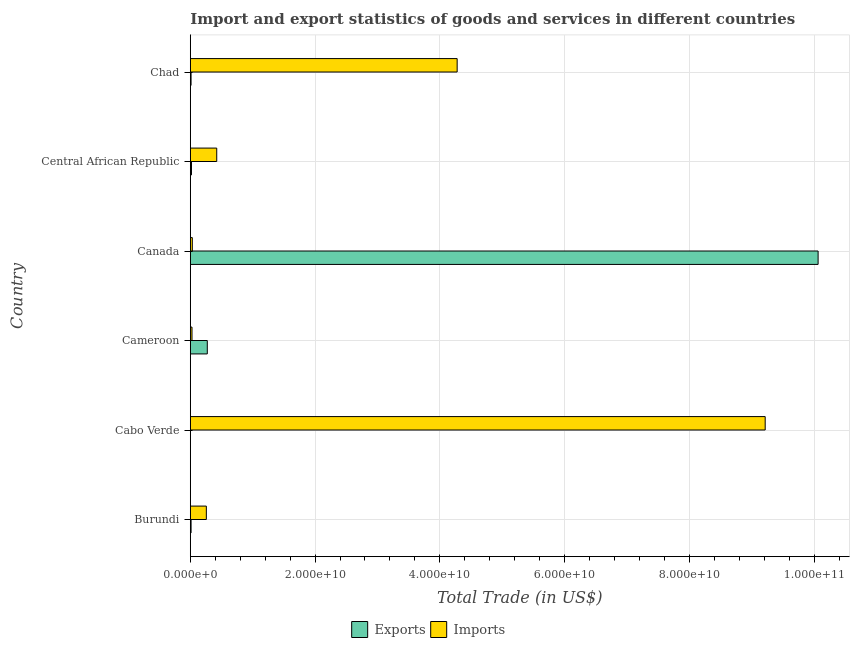Are the number of bars per tick equal to the number of legend labels?
Your answer should be very brief. Yes. What is the label of the 1st group of bars from the top?
Give a very brief answer. Chad. What is the imports of goods and services in Cabo Verde?
Offer a terse response. 9.22e+1. Across all countries, what is the maximum export of goods and services?
Offer a very short reply. 1.01e+11. Across all countries, what is the minimum imports of goods and services?
Offer a terse response. 2.74e+08. In which country was the imports of goods and services maximum?
Your response must be concise. Cabo Verde. In which country was the imports of goods and services minimum?
Your response must be concise. Cameroon. What is the total imports of goods and services in the graph?
Your answer should be compact. 1.42e+11. What is the difference between the export of goods and services in Cameroon and that in Chad?
Offer a very short reply. 2.60e+09. What is the difference between the export of goods and services in Burundi and the imports of goods and services in Cabo Verde?
Provide a succinct answer. -9.20e+1. What is the average export of goods and services per country?
Provide a succinct answer. 1.73e+1. What is the difference between the imports of goods and services and export of goods and services in Central African Republic?
Your response must be concise. 4.05e+09. What is the ratio of the imports of goods and services in Cameroon to that in Chad?
Provide a short and direct response. 0.01. Is the export of goods and services in Cameroon less than that in Chad?
Your answer should be very brief. No. Is the difference between the imports of goods and services in Cabo Verde and Central African Republic greater than the difference between the export of goods and services in Cabo Verde and Central African Republic?
Offer a terse response. Yes. What is the difference between the highest and the second highest export of goods and services?
Provide a succinct answer. 9.79e+1. What is the difference between the highest and the lowest export of goods and services?
Ensure brevity in your answer.  1.01e+11. In how many countries, is the export of goods and services greater than the average export of goods and services taken over all countries?
Your answer should be compact. 1. What does the 2nd bar from the top in Canada represents?
Keep it short and to the point. Exports. What does the 1st bar from the bottom in Chad represents?
Keep it short and to the point. Exports. Does the graph contain any zero values?
Ensure brevity in your answer.  No. Does the graph contain grids?
Offer a terse response. Yes. How are the legend labels stacked?
Offer a terse response. Horizontal. What is the title of the graph?
Offer a terse response. Import and export statistics of goods and services in different countries. What is the label or title of the X-axis?
Your answer should be very brief. Total Trade (in US$). What is the label or title of the Y-axis?
Make the answer very short. Country. What is the Total Trade (in US$) of Exports in Burundi?
Your answer should be very brief. 1.27e+08. What is the Total Trade (in US$) in Imports in Burundi?
Offer a terse response. 2.57e+09. What is the Total Trade (in US$) of Exports in Cabo Verde?
Ensure brevity in your answer.  3.12e+07. What is the Total Trade (in US$) in Imports in Cabo Verde?
Your answer should be compact. 9.22e+1. What is the Total Trade (in US$) in Exports in Cameroon?
Provide a succinct answer. 2.73e+09. What is the Total Trade (in US$) in Imports in Cameroon?
Give a very brief answer. 2.74e+08. What is the Total Trade (in US$) of Exports in Canada?
Offer a terse response. 1.01e+11. What is the Total Trade (in US$) of Imports in Canada?
Provide a succinct answer. 3.24e+08. What is the Total Trade (in US$) in Exports in Central African Republic?
Offer a very short reply. 1.90e+08. What is the Total Trade (in US$) of Imports in Central African Republic?
Give a very brief answer. 4.24e+09. What is the Total Trade (in US$) of Exports in Chad?
Your answer should be compact. 1.23e+08. What is the Total Trade (in US$) of Imports in Chad?
Your answer should be compact. 4.28e+1. Across all countries, what is the maximum Total Trade (in US$) of Exports?
Ensure brevity in your answer.  1.01e+11. Across all countries, what is the maximum Total Trade (in US$) of Imports?
Keep it short and to the point. 9.22e+1. Across all countries, what is the minimum Total Trade (in US$) of Exports?
Your answer should be compact. 3.12e+07. Across all countries, what is the minimum Total Trade (in US$) of Imports?
Your response must be concise. 2.74e+08. What is the total Total Trade (in US$) in Exports in the graph?
Offer a very short reply. 1.04e+11. What is the total Total Trade (in US$) of Imports in the graph?
Your answer should be very brief. 1.42e+11. What is the difference between the Total Trade (in US$) in Exports in Burundi and that in Cabo Verde?
Your answer should be very brief. 9.56e+07. What is the difference between the Total Trade (in US$) in Imports in Burundi and that in Cabo Verde?
Your response must be concise. -8.96e+1. What is the difference between the Total Trade (in US$) of Exports in Burundi and that in Cameroon?
Make the answer very short. -2.60e+09. What is the difference between the Total Trade (in US$) in Imports in Burundi and that in Cameroon?
Provide a succinct answer. 2.30e+09. What is the difference between the Total Trade (in US$) in Exports in Burundi and that in Canada?
Make the answer very short. -1.01e+11. What is the difference between the Total Trade (in US$) of Imports in Burundi and that in Canada?
Your answer should be very brief. 2.25e+09. What is the difference between the Total Trade (in US$) in Exports in Burundi and that in Central African Republic?
Offer a very short reply. -6.35e+07. What is the difference between the Total Trade (in US$) of Imports in Burundi and that in Central African Republic?
Give a very brief answer. -1.67e+09. What is the difference between the Total Trade (in US$) of Exports in Burundi and that in Chad?
Your response must be concise. 3.80e+06. What is the difference between the Total Trade (in US$) in Imports in Burundi and that in Chad?
Provide a succinct answer. -4.02e+1. What is the difference between the Total Trade (in US$) in Exports in Cabo Verde and that in Cameroon?
Give a very brief answer. -2.69e+09. What is the difference between the Total Trade (in US$) in Imports in Cabo Verde and that in Cameroon?
Keep it short and to the point. 9.19e+1. What is the difference between the Total Trade (in US$) in Exports in Cabo Verde and that in Canada?
Offer a terse response. -1.01e+11. What is the difference between the Total Trade (in US$) in Imports in Cabo Verde and that in Canada?
Ensure brevity in your answer.  9.18e+1. What is the difference between the Total Trade (in US$) of Exports in Cabo Verde and that in Central African Republic?
Offer a terse response. -1.59e+08. What is the difference between the Total Trade (in US$) in Imports in Cabo Verde and that in Central African Republic?
Keep it short and to the point. 8.79e+1. What is the difference between the Total Trade (in US$) in Exports in Cabo Verde and that in Chad?
Make the answer very short. -9.18e+07. What is the difference between the Total Trade (in US$) in Imports in Cabo Verde and that in Chad?
Your answer should be compact. 4.94e+1. What is the difference between the Total Trade (in US$) of Exports in Cameroon and that in Canada?
Offer a terse response. -9.79e+1. What is the difference between the Total Trade (in US$) in Imports in Cameroon and that in Canada?
Give a very brief answer. -5.00e+07. What is the difference between the Total Trade (in US$) in Exports in Cameroon and that in Central African Republic?
Your response must be concise. 2.54e+09. What is the difference between the Total Trade (in US$) of Imports in Cameroon and that in Central African Republic?
Make the answer very short. -3.97e+09. What is the difference between the Total Trade (in US$) of Exports in Cameroon and that in Chad?
Your response must be concise. 2.60e+09. What is the difference between the Total Trade (in US$) of Imports in Cameroon and that in Chad?
Give a very brief answer. -4.25e+1. What is the difference between the Total Trade (in US$) in Exports in Canada and that in Central African Republic?
Your response must be concise. 1.00e+11. What is the difference between the Total Trade (in US$) of Imports in Canada and that in Central African Republic?
Your answer should be very brief. -3.92e+09. What is the difference between the Total Trade (in US$) of Exports in Canada and that in Chad?
Your answer should be compact. 1.01e+11. What is the difference between the Total Trade (in US$) in Imports in Canada and that in Chad?
Your answer should be compact. -4.25e+1. What is the difference between the Total Trade (in US$) of Exports in Central African Republic and that in Chad?
Keep it short and to the point. 6.73e+07. What is the difference between the Total Trade (in US$) of Imports in Central African Republic and that in Chad?
Provide a succinct answer. -3.85e+1. What is the difference between the Total Trade (in US$) in Exports in Burundi and the Total Trade (in US$) in Imports in Cabo Verde?
Provide a short and direct response. -9.20e+1. What is the difference between the Total Trade (in US$) of Exports in Burundi and the Total Trade (in US$) of Imports in Cameroon?
Keep it short and to the point. -1.47e+08. What is the difference between the Total Trade (in US$) of Exports in Burundi and the Total Trade (in US$) of Imports in Canada?
Provide a short and direct response. -1.97e+08. What is the difference between the Total Trade (in US$) in Exports in Burundi and the Total Trade (in US$) in Imports in Central African Republic?
Your answer should be compact. -4.11e+09. What is the difference between the Total Trade (in US$) in Exports in Burundi and the Total Trade (in US$) in Imports in Chad?
Make the answer very short. -4.27e+1. What is the difference between the Total Trade (in US$) of Exports in Cabo Verde and the Total Trade (in US$) of Imports in Cameroon?
Make the answer very short. -2.42e+08. What is the difference between the Total Trade (in US$) of Exports in Cabo Verde and the Total Trade (in US$) of Imports in Canada?
Your response must be concise. -2.92e+08. What is the difference between the Total Trade (in US$) in Exports in Cabo Verde and the Total Trade (in US$) in Imports in Central African Republic?
Offer a very short reply. -4.21e+09. What is the difference between the Total Trade (in US$) in Exports in Cabo Verde and the Total Trade (in US$) in Imports in Chad?
Provide a succinct answer. -4.28e+1. What is the difference between the Total Trade (in US$) in Exports in Cameroon and the Total Trade (in US$) in Imports in Canada?
Keep it short and to the point. 2.40e+09. What is the difference between the Total Trade (in US$) of Exports in Cameroon and the Total Trade (in US$) of Imports in Central African Republic?
Offer a terse response. -1.51e+09. What is the difference between the Total Trade (in US$) in Exports in Cameroon and the Total Trade (in US$) in Imports in Chad?
Provide a short and direct response. -4.01e+1. What is the difference between the Total Trade (in US$) in Exports in Canada and the Total Trade (in US$) in Imports in Central African Republic?
Your answer should be very brief. 9.64e+1. What is the difference between the Total Trade (in US$) of Exports in Canada and the Total Trade (in US$) of Imports in Chad?
Provide a succinct answer. 5.79e+1. What is the difference between the Total Trade (in US$) of Exports in Central African Republic and the Total Trade (in US$) of Imports in Chad?
Keep it short and to the point. -4.26e+1. What is the average Total Trade (in US$) of Exports per country?
Your response must be concise. 1.73e+1. What is the average Total Trade (in US$) in Imports per country?
Ensure brevity in your answer.  2.37e+1. What is the difference between the Total Trade (in US$) of Exports and Total Trade (in US$) of Imports in Burundi?
Your answer should be very brief. -2.45e+09. What is the difference between the Total Trade (in US$) in Exports and Total Trade (in US$) in Imports in Cabo Verde?
Provide a succinct answer. -9.21e+1. What is the difference between the Total Trade (in US$) in Exports and Total Trade (in US$) in Imports in Cameroon?
Offer a terse response. 2.45e+09. What is the difference between the Total Trade (in US$) of Exports and Total Trade (in US$) of Imports in Canada?
Your response must be concise. 1.00e+11. What is the difference between the Total Trade (in US$) in Exports and Total Trade (in US$) in Imports in Central African Republic?
Offer a terse response. -4.05e+09. What is the difference between the Total Trade (in US$) in Exports and Total Trade (in US$) in Imports in Chad?
Keep it short and to the point. -4.27e+1. What is the ratio of the Total Trade (in US$) in Exports in Burundi to that in Cabo Verde?
Provide a short and direct response. 4.07. What is the ratio of the Total Trade (in US$) of Imports in Burundi to that in Cabo Verde?
Give a very brief answer. 0.03. What is the ratio of the Total Trade (in US$) in Exports in Burundi to that in Cameroon?
Your response must be concise. 0.05. What is the ratio of the Total Trade (in US$) in Imports in Burundi to that in Cameroon?
Offer a very short reply. 9.4. What is the ratio of the Total Trade (in US$) in Exports in Burundi to that in Canada?
Keep it short and to the point. 0. What is the ratio of the Total Trade (in US$) in Imports in Burundi to that in Canada?
Your answer should be very brief. 7.95. What is the ratio of the Total Trade (in US$) of Exports in Burundi to that in Central African Republic?
Ensure brevity in your answer.  0.67. What is the ratio of the Total Trade (in US$) of Imports in Burundi to that in Central African Republic?
Ensure brevity in your answer.  0.61. What is the ratio of the Total Trade (in US$) of Exports in Burundi to that in Chad?
Give a very brief answer. 1.03. What is the ratio of the Total Trade (in US$) of Imports in Burundi to that in Chad?
Make the answer very short. 0.06. What is the ratio of the Total Trade (in US$) in Exports in Cabo Verde to that in Cameroon?
Ensure brevity in your answer.  0.01. What is the ratio of the Total Trade (in US$) in Imports in Cabo Verde to that in Cameroon?
Keep it short and to the point. 336.87. What is the ratio of the Total Trade (in US$) of Imports in Cabo Verde to that in Canada?
Make the answer very short. 284.79. What is the ratio of the Total Trade (in US$) of Exports in Cabo Verde to that in Central African Republic?
Your response must be concise. 0.16. What is the ratio of the Total Trade (in US$) in Imports in Cabo Verde to that in Central African Republic?
Provide a succinct answer. 21.74. What is the ratio of the Total Trade (in US$) in Exports in Cabo Verde to that in Chad?
Your answer should be compact. 0.25. What is the ratio of the Total Trade (in US$) in Imports in Cabo Verde to that in Chad?
Give a very brief answer. 2.15. What is the ratio of the Total Trade (in US$) of Exports in Cameroon to that in Canada?
Provide a short and direct response. 0.03. What is the ratio of the Total Trade (in US$) in Imports in Cameroon to that in Canada?
Your response must be concise. 0.85. What is the ratio of the Total Trade (in US$) of Exports in Cameroon to that in Central African Republic?
Offer a terse response. 14.32. What is the ratio of the Total Trade (in US$) in Imports in Cameroon to that in Central African Republic?
Offer a terse response. 0.06. What is the ratio of the Total Trade (in US$) in Exports in Cameroon to that in Chad?
Your response must be concise. 22.16. What is the ratio of the Total Trade (in US$) in Imports in Cameroon to that in Chad?
Your answer should be very brief. 0.01. What is the ratio of the Total Trade (in US$) of Exports in Canada to that in Central African Republic?
Provide a short and direct response. 528.79. What is the ratio of the Total Trade (in US$) of Imports in Canada to that in Central African Republic?
Give a very brief answer. 0.08. What is the ratio of the Total Trade (in US$) in Exports in Canada to that in Chad?
Make the answer very short. 818.27. What is the ratio of the Total Trade (in US$) of Imports in Canada to that in Chad?
Provide a short and direct response. 0.01. What is the ratio of the Total Trade (in US$) of Exports in Central African Republic to that in Chad?
Keep it short and to the point. 1.55. What is the ratio of the Total Trade (in US$) of Imports in Central African Republic to that in Chad?
Provide a succinct answer. 0.1. What is the difference between the highest and the second highest Total Trade (in US$) in Exports?
Your answer should be compact. 9.79e+1. What is the difference between the highest and the second highest Total Trade (in US$) in Imports?
Give a very brief answer. 4.94e+1. What is the difference between the highest and the lowest Total Trade (in US$) in Exports?
Provide a succinct answer. 1.01e+11. What is the difference between the highest and the lowest Total Trade (in US$) of Imports?
Give a very brief answer. 9.19e+1. 